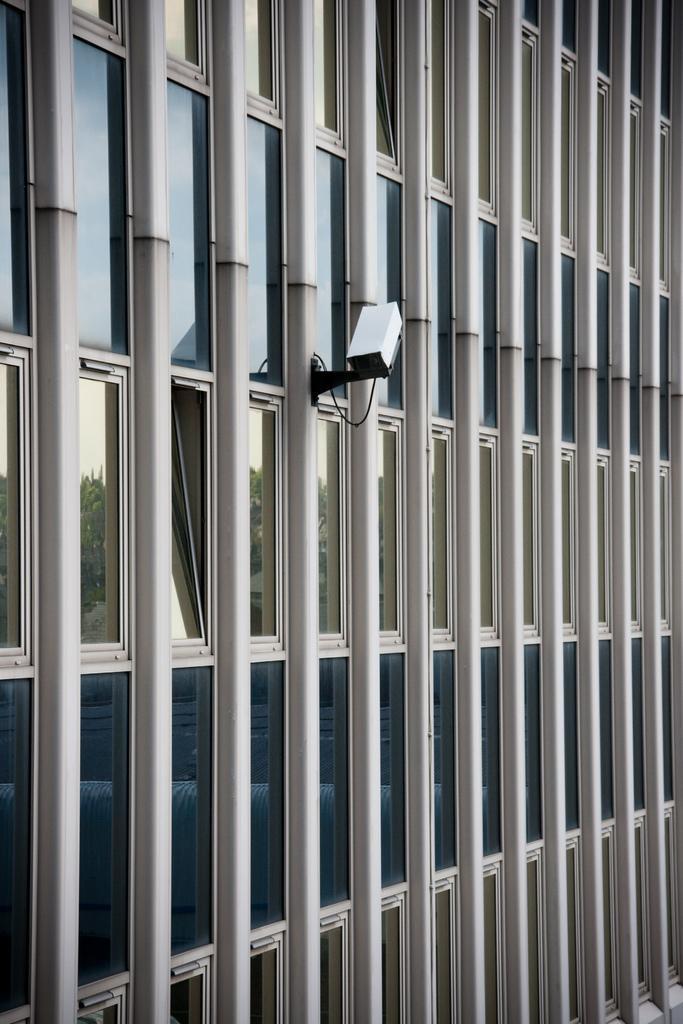Can you describe this image briefly? In this image I can see a building,glass windows and camera. I can see the reflection of the trees and sky. 